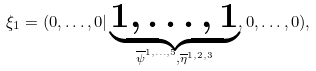<formula> <loc_0><loc_0><loc_500><loc_500>\xi _ { 1 } = ( 0 , \dots , 0 | \underbrace { 1 , \dots , 1 } _ { \overline { \psi } ^ { 1 , \dots , 5 } , \overline { \eta } ^ { 1 , 2 , 3 } } , 0 , \dots , 0 ) ,</formula> 